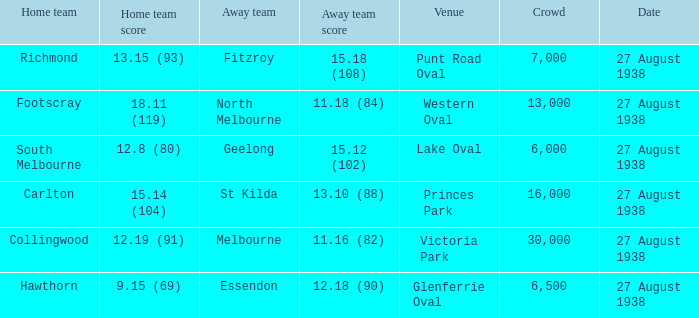How many people witnessed their home team score 13.15 (93)? 7000.0. 